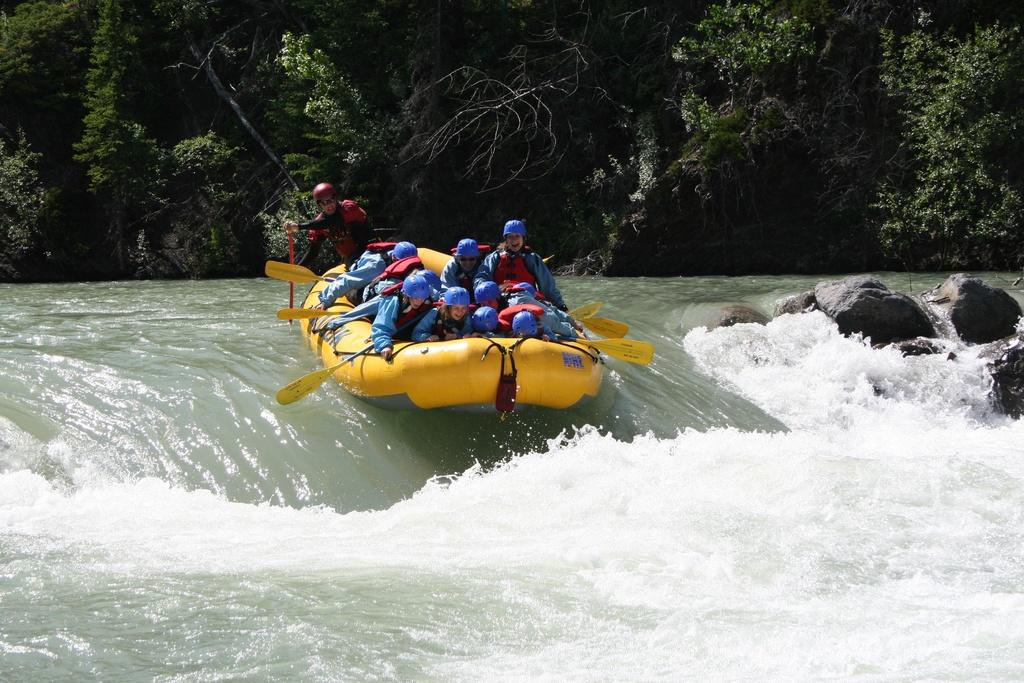What activity are the people in the image engaged in? The people in the image are rafting. Where are the people located in the image? The people are on the water. What can be seen in the background of the image? There are trees visible in the background of the image. What other objects or features can be seen in the image? There are rocks in the image. What type of industry can be seen in the background of the image? There is no industry visible in the background of the image; it features trees and water. What book is the person reading while rafting in the image? There is no person reading a book in the image; the people are rafting on the water. 